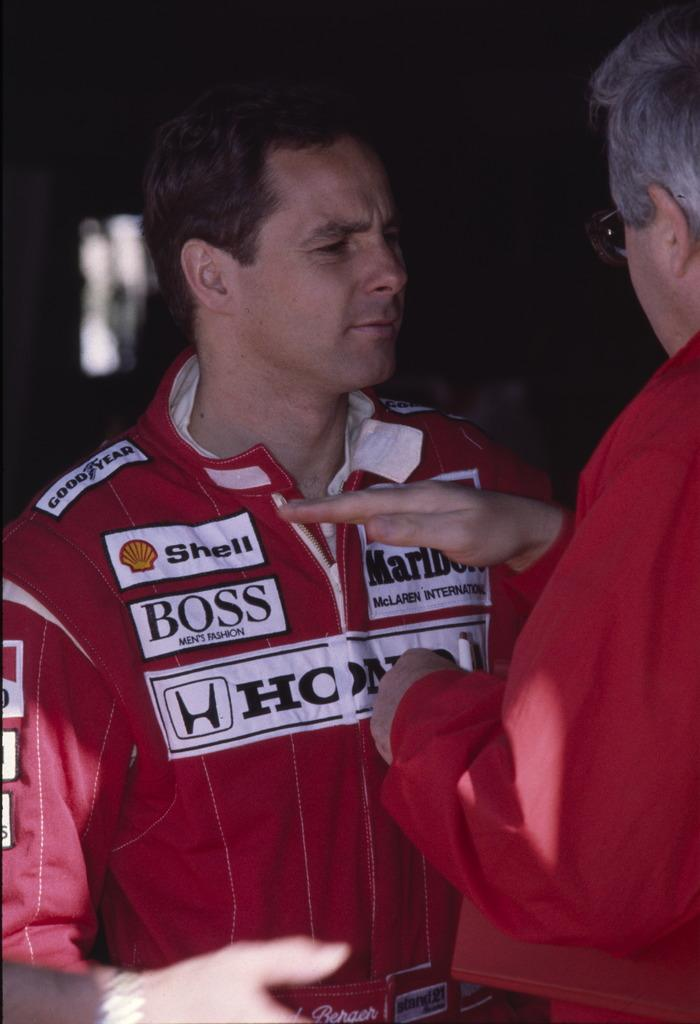Provide a one-sentence caption for the provided image. An older man speaks to a younger man in a red coverall suit with a Shell patch. 